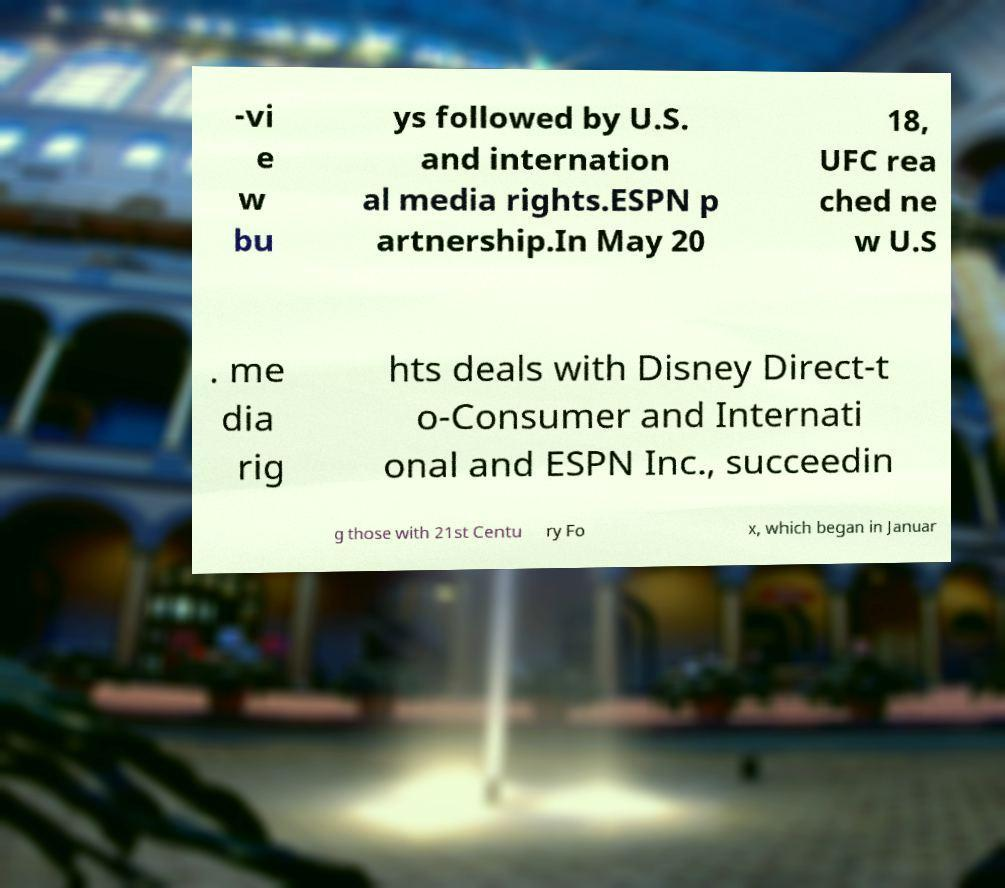Could you extract and type out the text from this image? -vi e w bu ys followed by U.S. and internation al media rights.ESPN p artnership.In May 20 18, UFC rea ched ne w U.S . me dia rig hts deals with Disney Direct-t o-Consumer and Internati onal and ESPN Inc., succeedin g those with 21st Centu ry Fo x, which began in Januar 